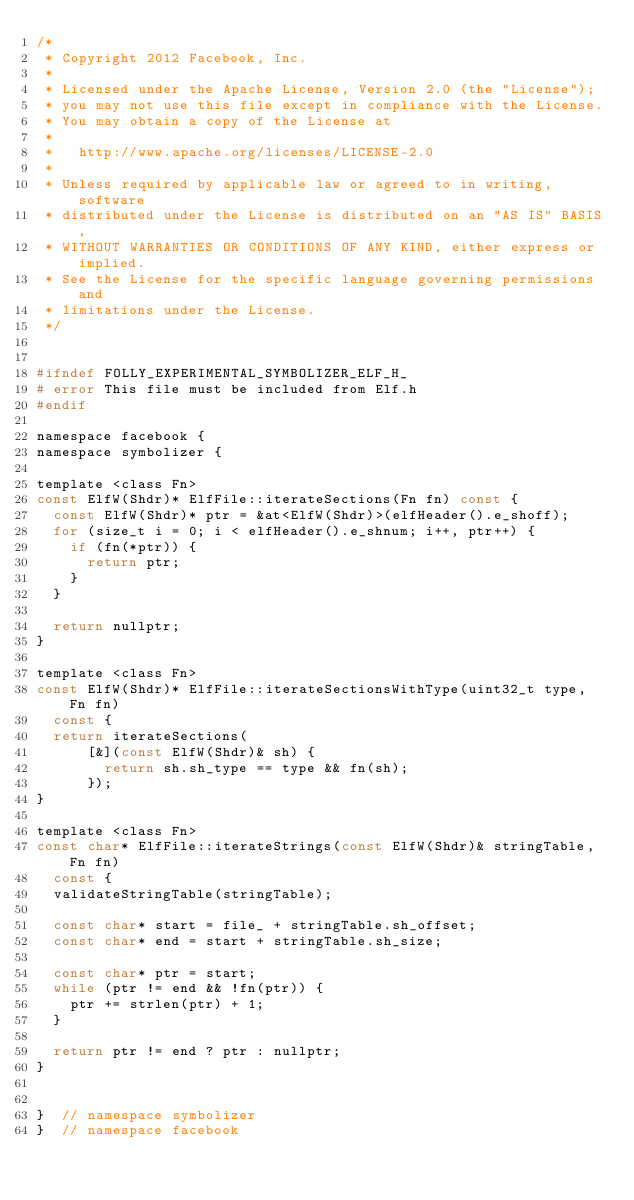Convert code to text. <code><loc_0><loc_0><loc_500><loc_500><_C_>/*
 * Copyright 2012 Facebook, Inc.
 *
 * Licensed under the Apache License, Version 2.0 (the "License");
 * you may not use this file except in compliance with the License.
 * You may obtain a copy of the License at
 *
 *   http://www.apache.org/licenses/LICENSE-2.0
 *
 * Unless required by applicable law or agreed to in writing, software
 * distributed under the License is distributed on an "AS IS" BASIS,
 * WITHOUT WARRANTIES OR CONDITIONS OF ANY KIND, either express or implied.
 * See the License for the specific language governing permissions and
 * limitations under the License.
 */


#ifndef FOLLY_EXPERIMENTAL_SYMBOLIZER_ELF_H_
# error This file must be included from Elf.h
#endif

namespace facebook {
namespace symbolizer {

template <class Fn>
const ElfW(Shdr)* ElfFile::iterateSections(Fn fn) const {
  const ElfW(Shdr)* ptr = &at<ElfW(Shdr)>(elfHeader().e_shoff);
  for (size_t i = 0; i < elfHeader().e_shnum; i++, ptr++) {
    if (fn(*ptr)) {
      return ptr;
    }
  }

  return nullptr;
}

template <class Fn>
const ElfW(Shdr)* ElfFile::iterateSectionsWithType(uint32_t type, Fn fn)
  const {
  return iterateSections(
      [&](const ElfW(Shdr)& sh) {
        return sh.sh_type == type && fn(sh);
      });
}

template <class Fn>
const char* ElfFile::iterateStrings(const ElfW(Shdr)& stringTable, Fn fn)
  const {
  validateStringTable(stringTable);

  const char* start = file_ + stringTable.sh_offset;
  const char* end = start + stringTable.sh_size;

  const char* ptr = start;
  while (ptr != end && !fn(ptr)) {
    ptr += strlen(ptr) + 1;
  }

  return ptr != end ? ptr : nullptr;
}


}  // namespace symbolizer
}  // namespace facebook

</code> 